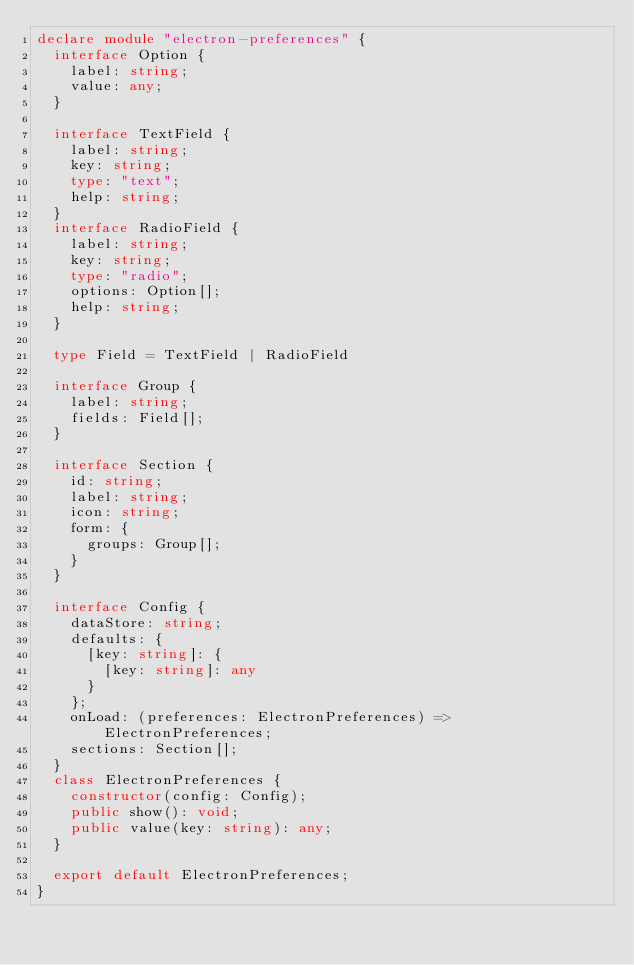<code> <loc_0><loc_0><loc_500><loc_500><_TypeScript_>declare module "electron-preferences" {
  interface Option {
    label: string;
    value: any;
  }

  interface TextField {
    label: string;
    key: string;
    type: "text";
    help: string;
  }
  interface RadioField {
    label: string;
    key: string;
    type: "radio";
    options: Option[];
    help: string;
  }

  type Field = TextField | RadioField

  interface Group {
    label: string;
    fields: Field[];
  }

  interface Section {
    id: string;
    label: string;
    icon: string;
    form: {
      groups: Group[];
    }
  }

  interface Config {
    dataStore: string;
    defaults: {
      [key: string]: {
        [key: string]: any
      }
    };
    onLoad: (preferences: ElectronPreferences) => ElectronPreferences;
    sections: Section[];
  }
  class ElectronPreferences {
    constructor(config: Config);
    public show(): void;
    public value(key: string): any;
  }

  export default ElectronPreferences;
}
</code> 